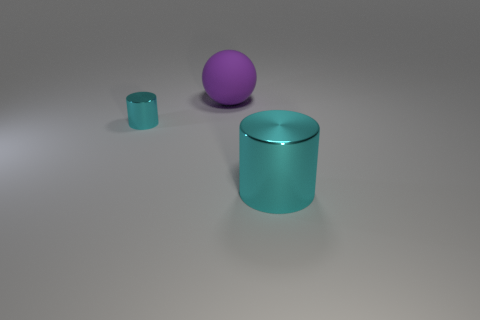Given the positions of the objects, could this be an artistic arrangement? Certainly, the arrangement of the objects with varying sizes and colors could be seen as an artistic composition that explores balance and scale. The simplicity of the scene and the placement might suggest an intentional design meant to highlight these aspects. 